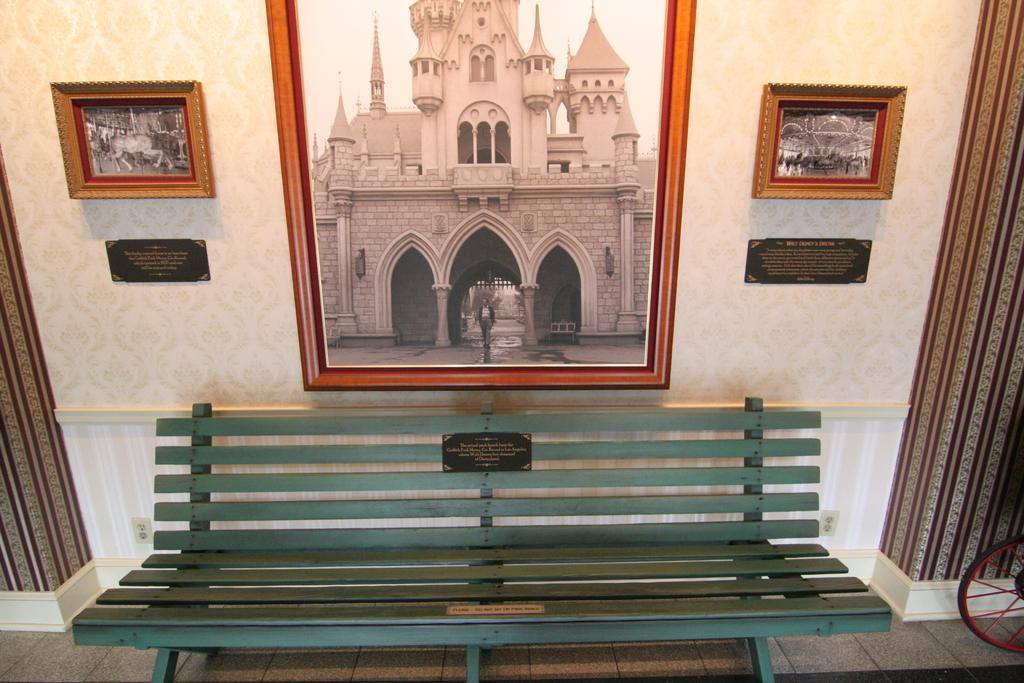What type of seating is present on the path in the image? There is a bench on the path in the image. What architectural features can be seen on the wall in the image? There are pillars and frames on the wall in the image. What is located on the left side of the image? There is a wheel on the left side of the image. Can you see any lettuce growing on the wall in the image? There is no lettuce present in the image; it features a bench, pillars, frames, and a wheel. How does the comb help the cave in the image? There is no cave or comb present in the image. 